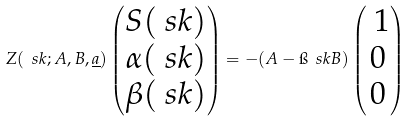<formula> <loc_0><loc_0><loc_500><loc_500>Z ( \ s k ; A , B , \underline { a } ) \begin{pmatrix} S ( \ s k ) \\ \alpha ( \ s k ) \\ \beta ( \ s k ) \end{pmatrix} = - ( A - \i \ s k B ) \begin{pmatrix} \ 1 \\ 0 \\ 0 \end{pmatrix}</formula> 